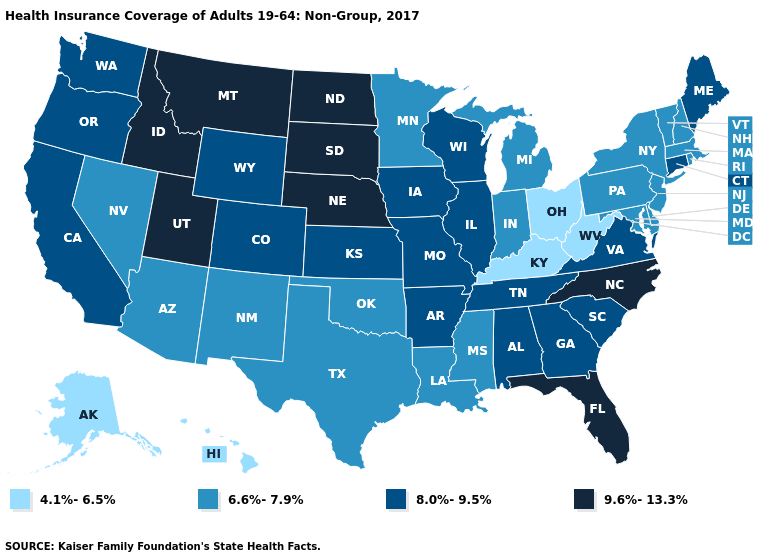Does New Mexico have the lowest value in the USA?
Give a very brief answer. No. Name the states that have a value in the range 4.1%-6.5%?
Concise answer only. Alaska, Hawaii, Kentucky, Ohio, West Virginia. What is the lowest value in states that border Nevada?
Give a very brief answer. 6.6%-7.9%. What is the value of Vermont?
Concise answer only. 6.6%-7.9%. What is the value of Iowa?
Quick response, please. 8.0%-9.5%. Name the states that have a value in the range 9.6%-13.3%?
Answer briefly. Florida, Idaho, Montana, Nebraska, North Carolina, North Dakota, South Dakota, Utah. Name the states that have a value in the range 8.0%-9.5%?
Answer briefly. Alabama, Arkansas, California, Colorado, Connecticut, Georgia, Illinois, Iowa, Kansas, Maine, Missouri, Oregon, South Carolina, Tennessee, Virginia, Washington, Wisconsin, Wyoming. Does South Dakota have the lowest value in the MidWest?
Answer briefly. No. What is the value of Virginia?
Keep it brief. 8.0%-9.5%. Name the states that have a value in the range 4.1%-6.5%?
Be succinct. Alaska, Hawaii, Kentucky, Ohio, West Virginia. What is the value of Georgia?
Keep it brief. 8.0%-9.5%. What is the value of Texas?
Be succinct. 6.6%-7.9%. 